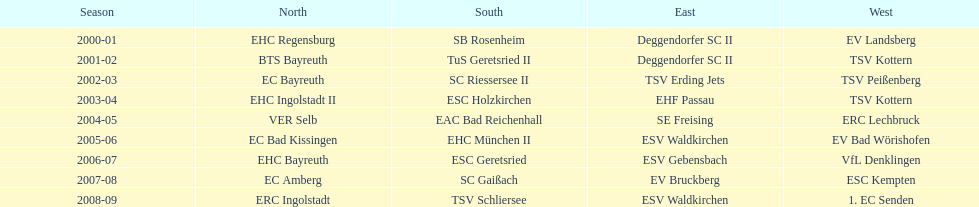Can you parse all the data within this table? {'header': ['Season', 'North', 'South', 'East', 'West'], 'rows': [['2000-01', 'EHC Regensburg', 'SB Rosenheim', 'Deggendorfer SC II', 'EV Landsberg'], ['2001-02', 'BTS Bayreuth', 'TuS Geretsried II', 'Deggendorfer SC II', 'TSV Kottern'], ['2002-03', 'EC Bayreuth', 'SC Riessersee II', 'TSV Erding Jets', 'TSV Peißenberg'], ['2003-04', 'EHC Ingolstadt II', 'ESC Holzkirchen', 'EHF Passau', 'TSV Kottern'], ['2004-05', 'VER Selb', 'EAC Bad Reichenhall', 'SE Freising', 'ERC Lechbruck'], ['2005-06', 'EC Bad Kissingen', 'EHC München II', 'ESV Waldkirchen', 'EV Bad Wörishofen'], ['2006-07', 'EHC Bayreuth', 'ESC Geretsried', 'ESV Gebensbach', 'VfL Denklingen'], ['2007-08', 'EC Amberg', 'SC Gaißach', 'EV Bruckberg', 'ESC Kempten'], ['2008-09', 'ERC Ingolstadt', 'TSV Schliersee', 'ESV Waldkirchen', '1. EC Senden']]} Between 2000 and 2009, which teams emerged victorious in the bavarian ice hockey leagues? EHC Regensburg, SB Rosenheim, Deggendorfer SC II, EV Landsberg, BTS Bayreuth, TuS Geretsried II, TSV Kottern, EC Bayreuth, SC Riessersee II, TSV Erding Jets, TSV Peißenberg, EHC Ingolstadt II, ESC Holzkirchen, EHF Passau, TSV Kottern, VER Selb, EAC Bad Reichenhall, SE Freising, ERC Lechbruck, EC Bad Kissingen, EHC München II, ESV Waldkirchen, EV Bad Wörishofen, EHC Bayreuth, ESC Geretsried, ESV Gebensbach, VfL Denklingen, EC Amberg, SC Gaißach, EV Bruckberg, ESC Kempten, ERC Ingolstadt, TSV Schliersee, ESV Waldkirchen, 1. EC Senden. Among these champions, which ones secured a win in the northern division? EHC Regensburg, BTS Bayreuth, EC Bayreuth, EHC Ingolstadt II, VER Selb, EC Bad Kissingen, EHC Bayreuth, EC Amberg, ERC Ingolstadt. Lastly, which northern division winners claimed victory during the 2000/2001 season? EHC Regensburg. 